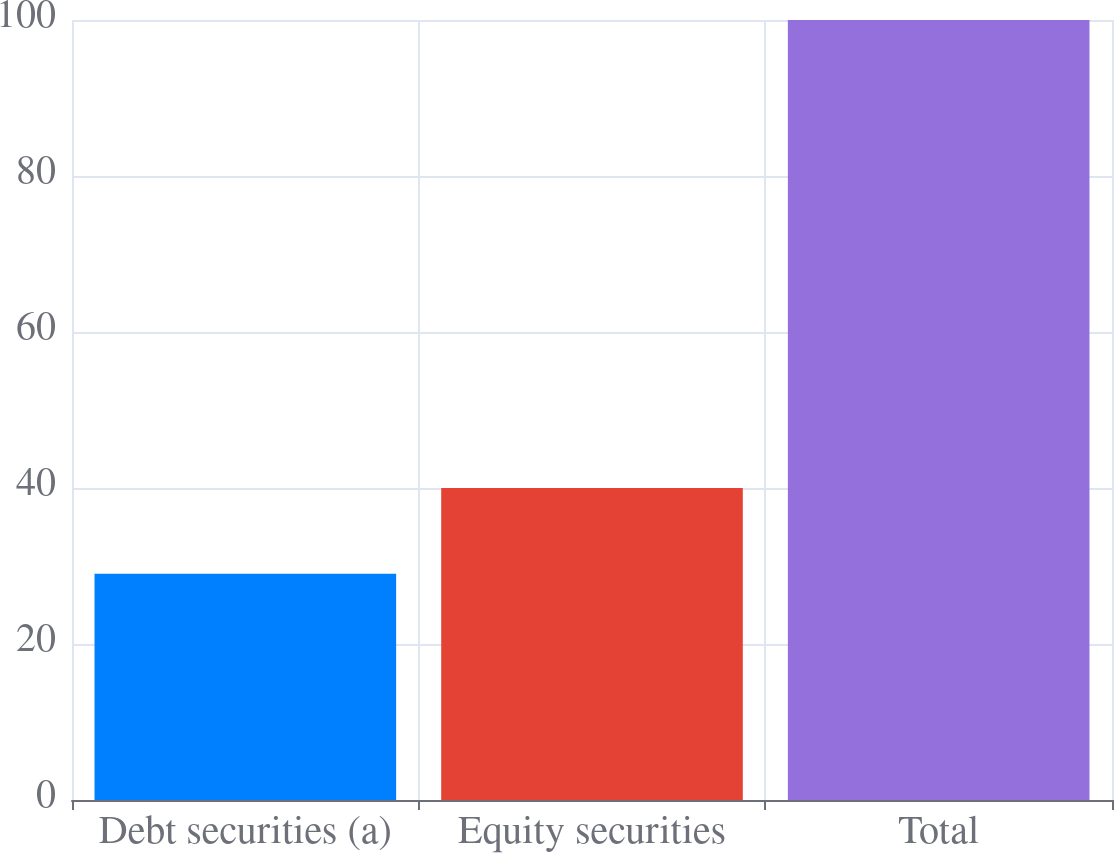<chart> <loc_0><loc_0><loc_500><loc_500><bar_chart><fcel>Debt securities (a)<fcel>Equity securities<fcel>Total<nl><fcel>29<fcel>40<fcel>100<nl></chart> 